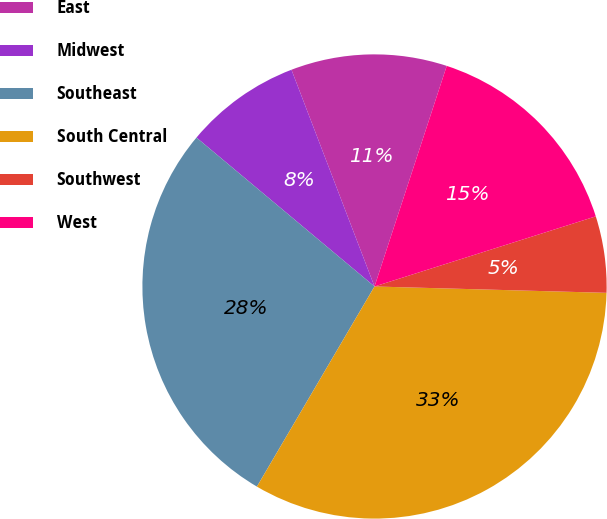<chart> <loc_0><loc_0><loc_500><loc_500><pie_chart><fcel>East<fcel>Midwest<fcel>Southeast<fcel>South Central<fcel>Southwest<fcel>West<nl><fcel>10.86%<fcel>8.09%<fcel>27.63%<fcel>33.02%<fcel>5.32%<fcel>15.08%<nl></chart> 